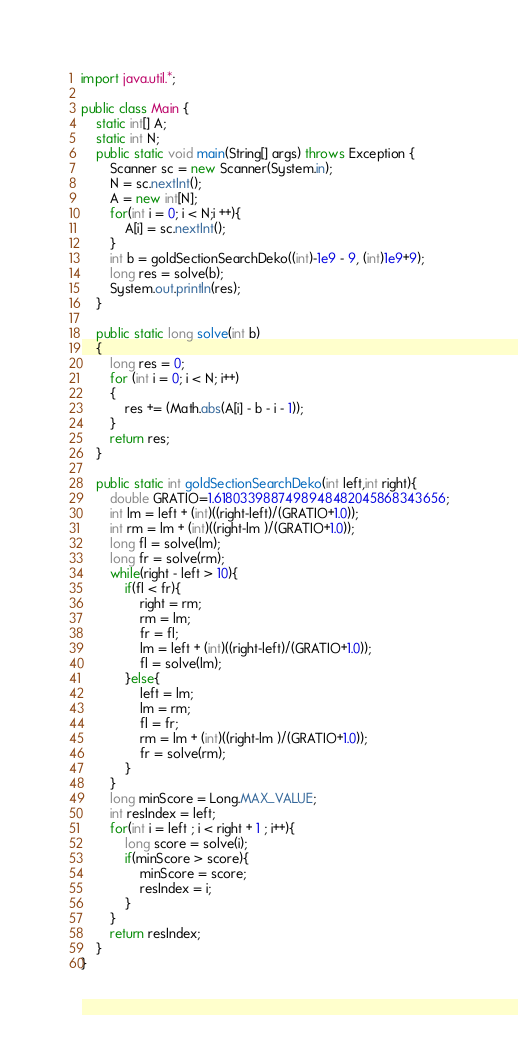<code> <loc_0><loc_0><loc_500><loc_500><_Java_>import java.util.*;

public class Main {
    static int[] A;
    static int N;
    public static void main(String[] args) throws Exception {
        Scanner sc = new Scanner(System.in);
        N = sc.nextInt();
        A = new int[N];
        for(int i = 0; i < N;i ++){
            A[i] = sc.nextInt();
        }
        int b = goldSectionSearchDeko((int)-1e9 - 9, (int)1e9+9);
        long res = solve(b);
        System.out.println(res);
    }
    
    public static long solve(int b)
    {
        long res = 0;
        for (int i = 0; i < N; i++)
        {
            res += (Math.abs(A[i] - b - i - 1));
        }
        return res;
    }
    
    public static int goldSectionSearchDeko(int left,int right){
        double GRATIO=1.6180339887498948482045868343656;
        int lm = left + (int)((right-left)/(GRATIO+1.0));
        int rm = lm + (int)((right-lm )/(GRATIO+1.0));
        long fl = solve(lm);
        long fr = solve(rm);
        while(right - left > 10){
            if(fl < fr){
                right = rm;
                rm = lm;
                fr = fl;
                lm = left + (int)((right-left)/(GRATIO+1.0));
                fl = solve(lm);
            }else{
                left = lm;
                lm = rm;
                fl = fr;
                rm = lm + (int)((right-lm )/(GRATIO+1.0));
                fr = solve(rm);
            }
        }
        long minScore = Long.MAX_VALUE;
        int resIndex = left;
        for(int i = left ; i < right + 1 ; i++){
            long score = solve(i);
            if(minScore > score){
                minScore = score;
                resIndex = i;
            }
        }
        return resIndex;
    }
}
</code> 